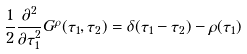<formula> <loc_0><loc_0><loc_500><loc_500>\frac { 1 } { 2 } \frac { \partial ^ { 2 } } { \partial \tau _ { 1 } ^ { 2 } } G ^ { \rho } ( \tau _ { 1 } , \tau _ { 2 } ) = \delta ( \tau _ { 1 } - \tau _ { 2 } ) - \rho ( \tau _ { 1 } )</formula> 